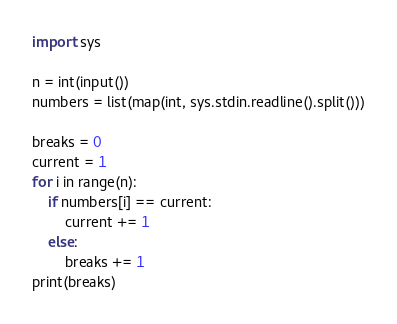<code> <loc_0><loc_0><loc_500><loc_500><_Python_>import sys

n = int(input())
numbers = list(map(int, sys.stdin.readline().split()))

breaks = 0
current = 1
for i in range(n):
    if numbers[i] == current:
        current += 1
    else:
        breaks += 1
print(breaks)
</code> 